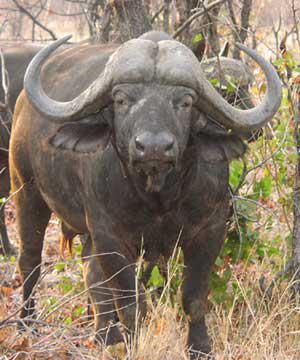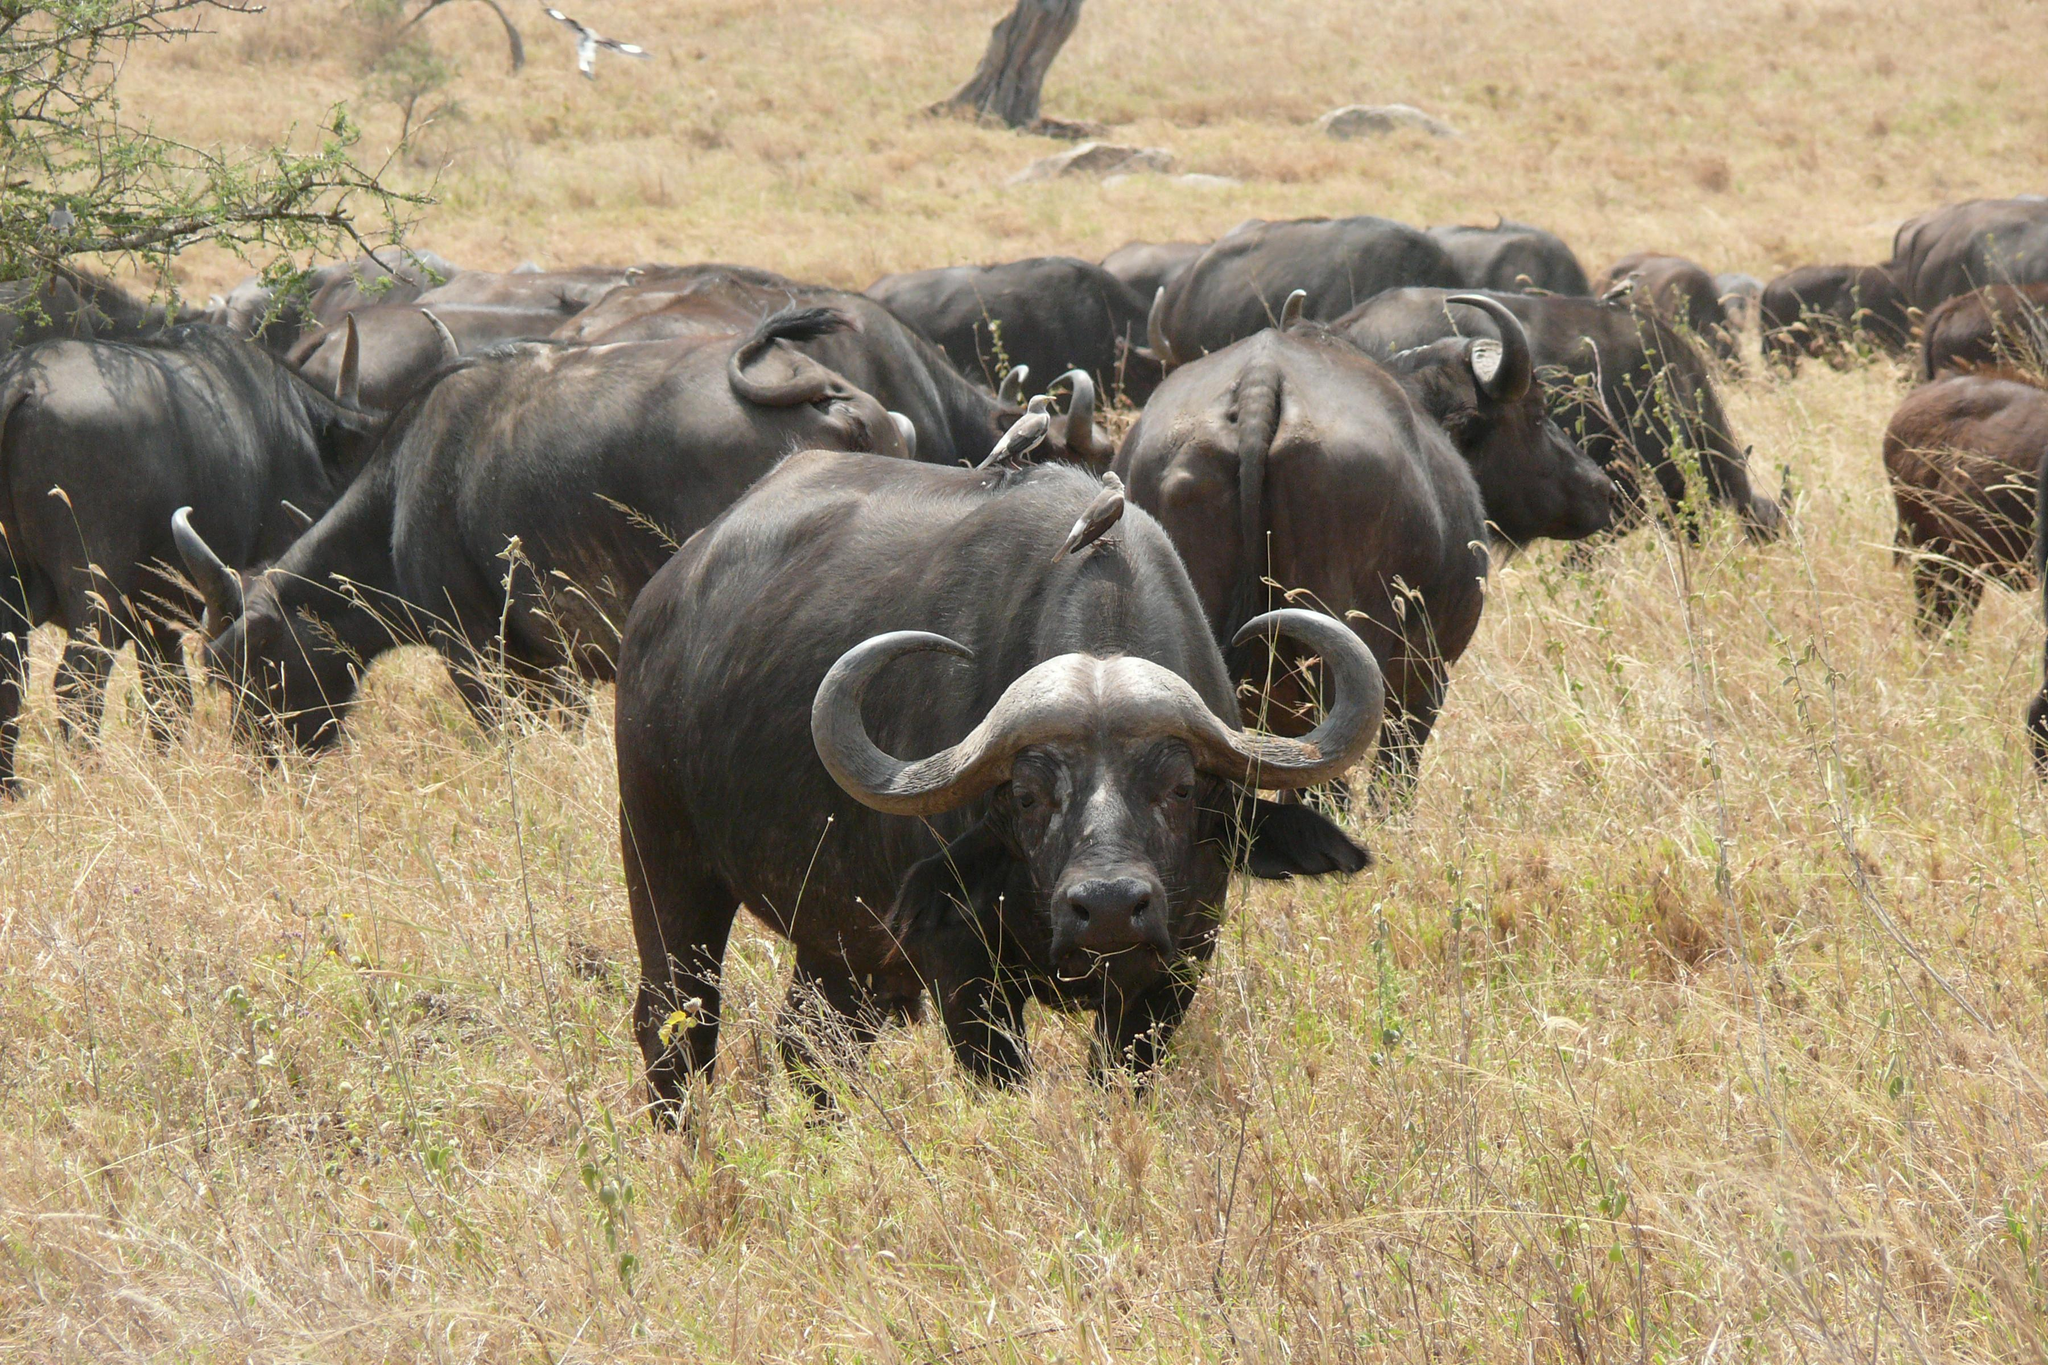The first image is the image on the left, the second image is the image on the right. Assess this claim about the two images: "None of the animals are near the water.". Correct or not? Answer yes or no. Yes. The first image is the image on the left, the second image is the image on the right. Given the left and right images, does the statement "Left image shows one forward-facing water buffalo standing on dry ground." hold true? Answer yes or no. Yes. 